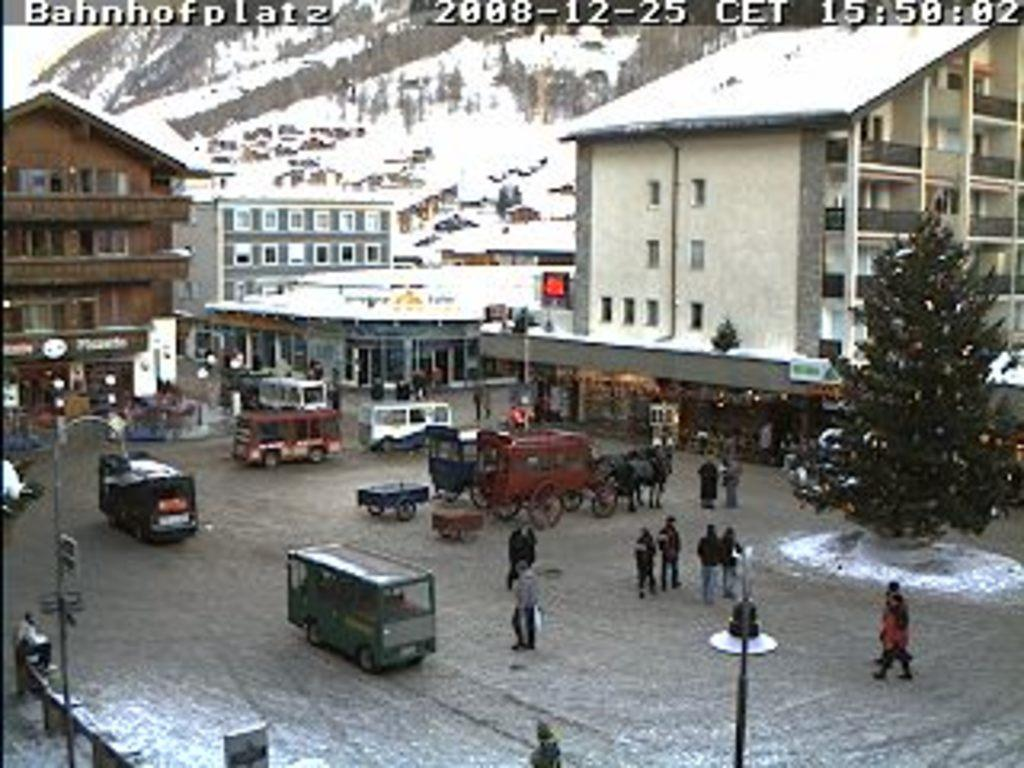What types of objects are present in the image that are used for transportation? There are vehicles in the image. What types of objects are present in the image that are used for carrying items? There are carts in the image. What types of living beings are present in the image? There are people in the image. What types of structures are present in the image that provide light? There are light poles in the image. What types of natural elements are present in the image? There are trees in the image. What types of structures are present in the image that have windows? There is a building with windows in the image. What type of vase is present in the image? There is no vase present in the image. What direction are the people in the image facing? The direction the people are facing cannot be determined from the image. 